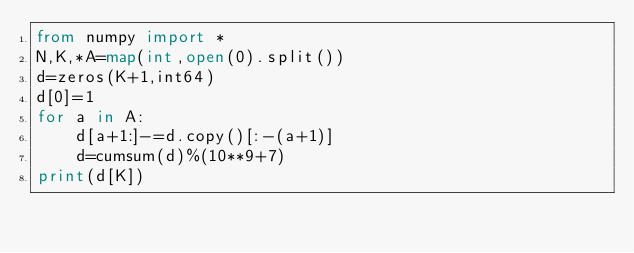<code> <loc_0><loc_0><loc_500><loc_500><_Python_>from numpy import *
N,K,*A=map(int,open(0).split())
d=zeros(K+1,int64)
d[0]=1
for a in A:
    d[a+1:]-=d.copy()[:-(a+1)]
    d=cumsum(d)%(10**9+7)
print(d[K])</code> 